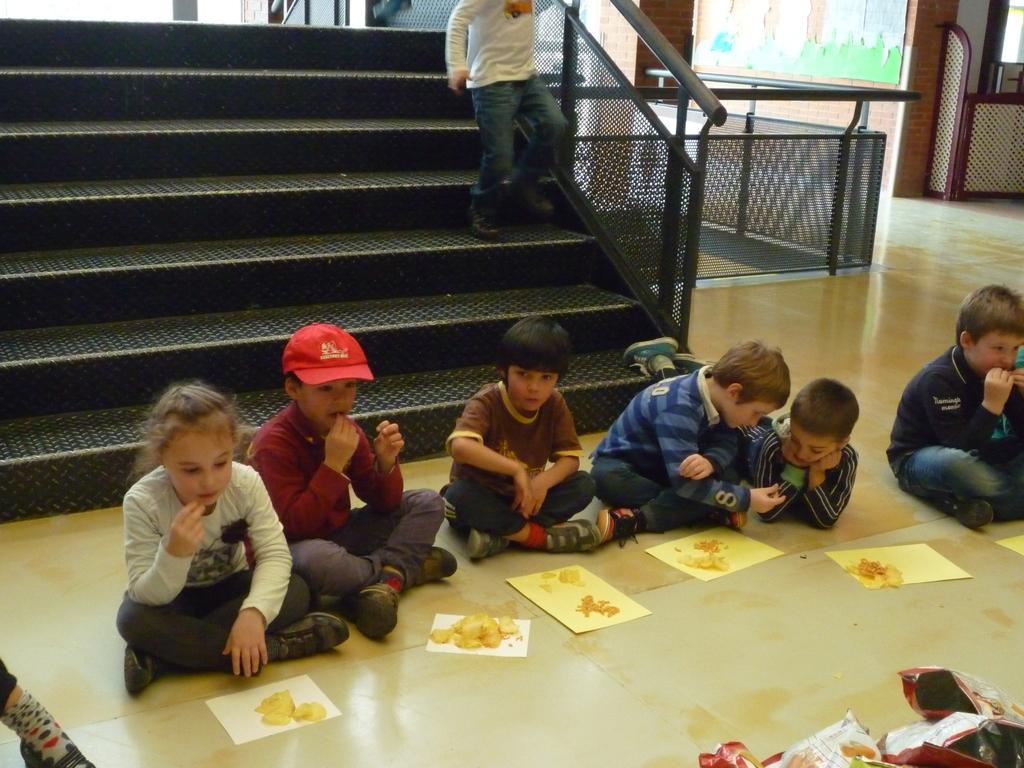Can you describe this image briefly? In this picture we can see a group of children sitting on the floor and in front of them we can see papers with food on it, packets and at the back of them we can see a person on steps, fences and some objects. 